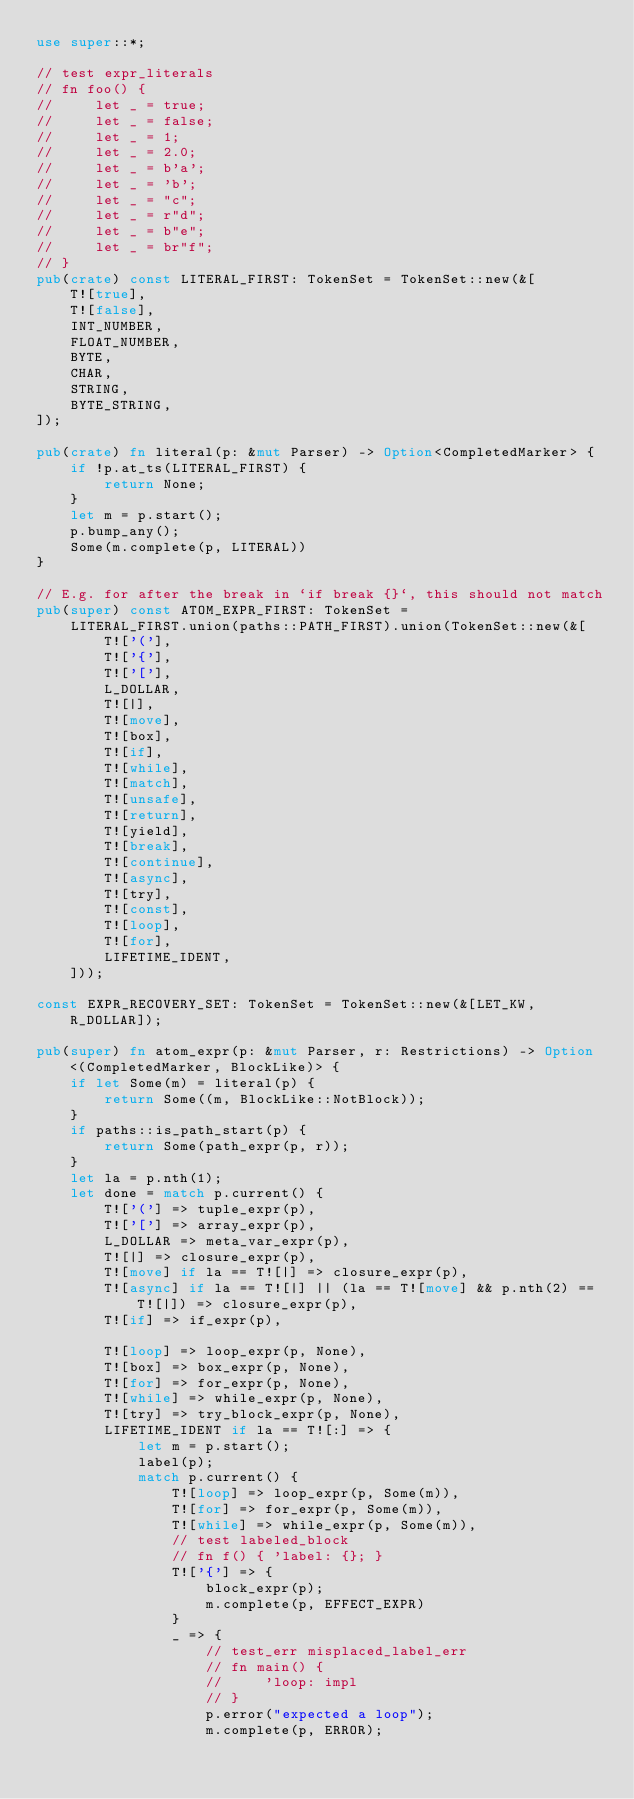Convert code to text. <code><loc_0><loc_0><loc_500><loc_500><_Rust_>use super::*;

// test expr_literals
// fn foo() {
//     let _ = true;
//     let _ = false;
//     let _ = 1;
//     let _ = 2.0;
//     let _ = b'a';
//     let _ = 'b';
//     let _ = "c";
//     let _ = r"d";
//     let _ = b"e";
//     let _ = br"f";
// }
pub(crate) const LITERAL_FIRST: TokenSet = TokenSet::new(&[
    T![true],
    T![false],
    INT_NUMBER,
    FLOAT_NUMBER,
    BYTE,
    CHAR,
    STRING,
    BYTE_STRING,
]);

pub(crate) fn literal(p: &mut Parser) -> Option<CompletedMarker> {
    if !p.at_ts(LITERAL_FIRST) {
        return None;
    }
    let m = p.start();
    p.bump_any();
    Some(m.complete(p, LITERAL))
}

// E.g. for after the break in `if break {}`, this should not match
pub(super) const ATOM_EXPR_FIRST: TokenSet =
    LITERAL_FIRST.union(paths::PATH_FIRST).union(TokenSet::new(&[
        T!['('],
        T!['{'],
        T!['['],
        L_DOLLAR,
        T![|],
        T![move],
        T![box],
        T![if],
        T![while],
        T![match],
        T![unsafe],
        T![return],
        T![yield],
        T![break],
        T![continue],
        T![async],
        T![try],
        T![const],
        T![loop],
        T![for],
        LIFETIME_IDENT,
    ]));

const EXPR_RECOVERY_SET: TokenSet = TokenSet::new(&[LET_KW, R_DOLLAR]);

pub(super) fn atom_expr(p: &mut Parser, r: Restrictions) -> Option<(CompletedMarker, BlockLike)> {
    if let Some(m) = literal(p) {
        return Some((m, BlockLike::NotBlock));
    }
    if paths::is_path_start(p) {
        return Some(path_expr(p, r));
    }
    let la = p.nth(1);
    let done = match p.current() {
        T!['('] => tuple_expr(p),
        T!['['] => array_expr(p),
        L_DOLLAR => meta_var_expr(p),
        T![|] => closure_expr(p),
        T![move] if la == T![|] => closure_expr(p),
        T![async] if la == T![|] || (la == T![move] && p.nth(2) == T![|]) => closure_expr(p),
        T![if] => if_expr(p),

        T![loop] => loop_expr(p, None),
        T![box] => box_expr(p, None),
        T![for] => for_expr(p, None),
        T![while] => while_expr(p, None),
        T![try] => try_block_expr(p, None),
        LIFETIME_IDENT if la == T![:] => {
            let m = p.start();
            label(p);
            match p.current() {
                T![loop] => loop_expr(p, Some(m)),
                T![for] => for_expr(p, Some(m)),
                T![while] => while_expr(p, Some(m)),
                // test labeled_block
                // fn f() { 'label: {}; }
                T!['{'] => {
                    block_expr(p);
                    m.complete(p, EFFECT_EXPR)
                }
                _ => {
                    // test_err misplaced_label_err
                    // fn main() {
                    //     'loop: impl
                    // }
                    p.error("expected a loop");
                    m.complete(p, ERROR);</code> 